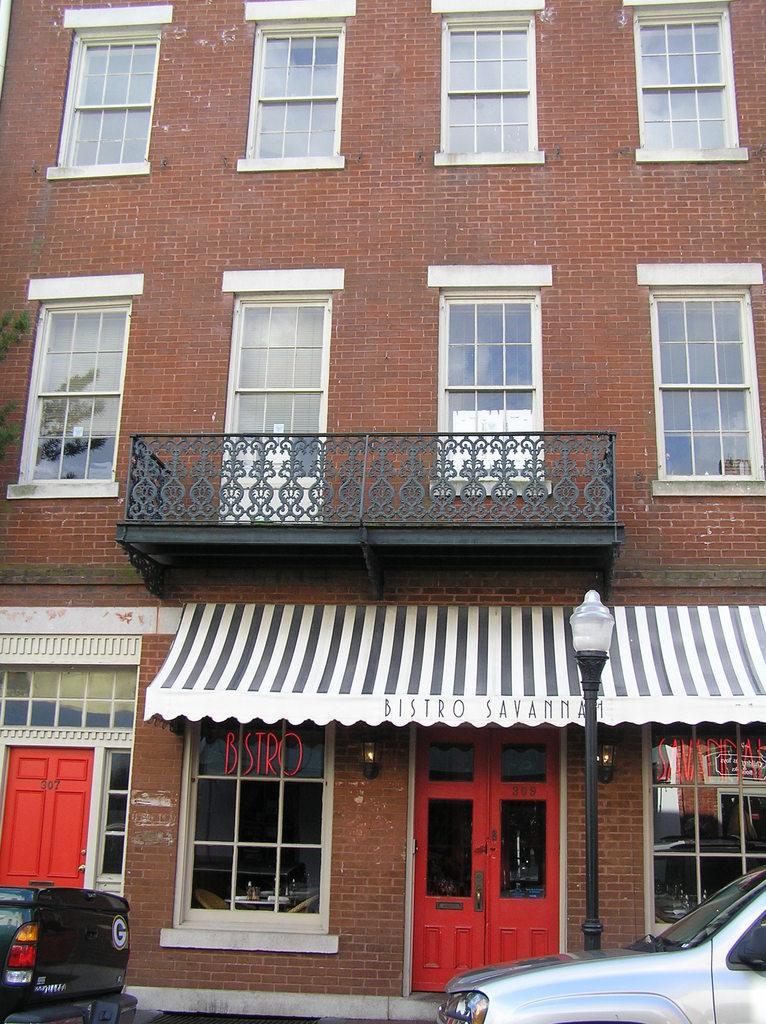In one or two sentences, can you explain what this image depicts? In this image we can see there is a building, in front of the building there are two vehicles parked. 